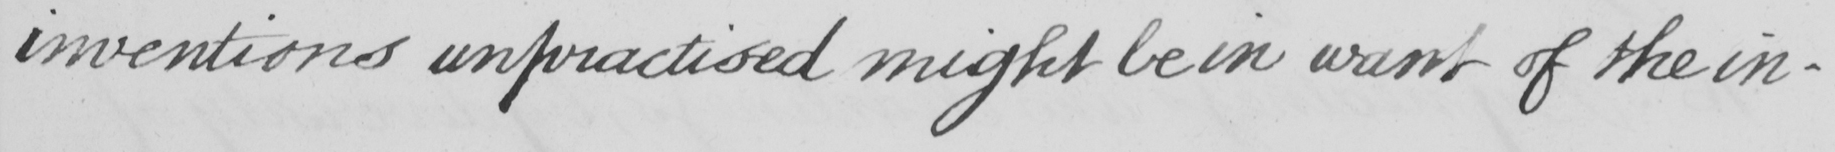What is written in this line of handwriting? inventions unpractised might be in want of the in- 